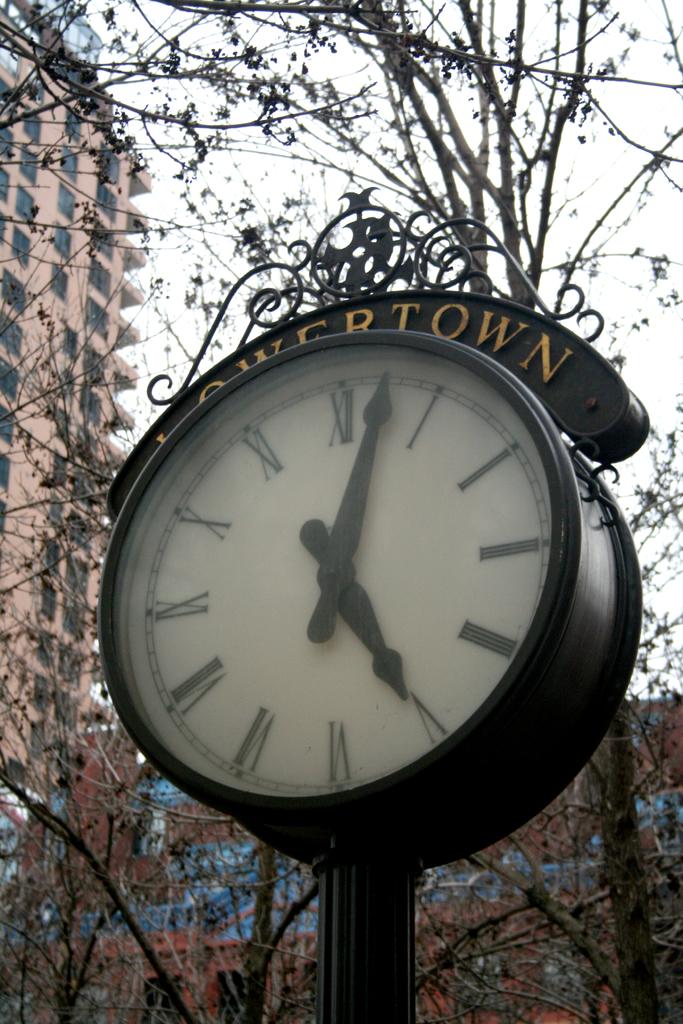What time is it?
Offer a very short reply. 5:03. Is this clock in a town?
Ensure brevity in your answer.  Yes. 